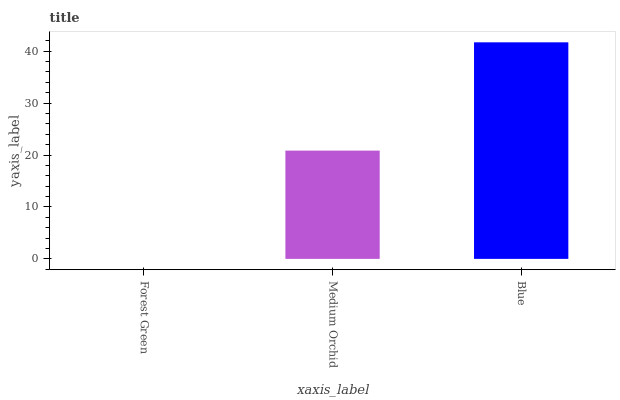Is Medium Orchid the minimum?
Answer yes or no. No. Is Medium Orchid the maximum?
Answer yes or no. No. Is Medium Orchid greater than Forest Green?
Answer yes or no. Yes. Is Forest Green less than Medium Orchid?
Answer yes or no. Yes. Is Forest Green greater than Medium Orchid?
Answer yes or no. No. Is Medium Orchid less than Forest Green?
Answer yes or no. No. Is Medium Orchid the high median?
Answer yes or no. Yes. Is Medium Orchid the low median?
Answer yes or no. Yes. Is Forest Green the high median?
Answer yes or no. No. Is Forest Green the low median?
Answer yes or no. No. 